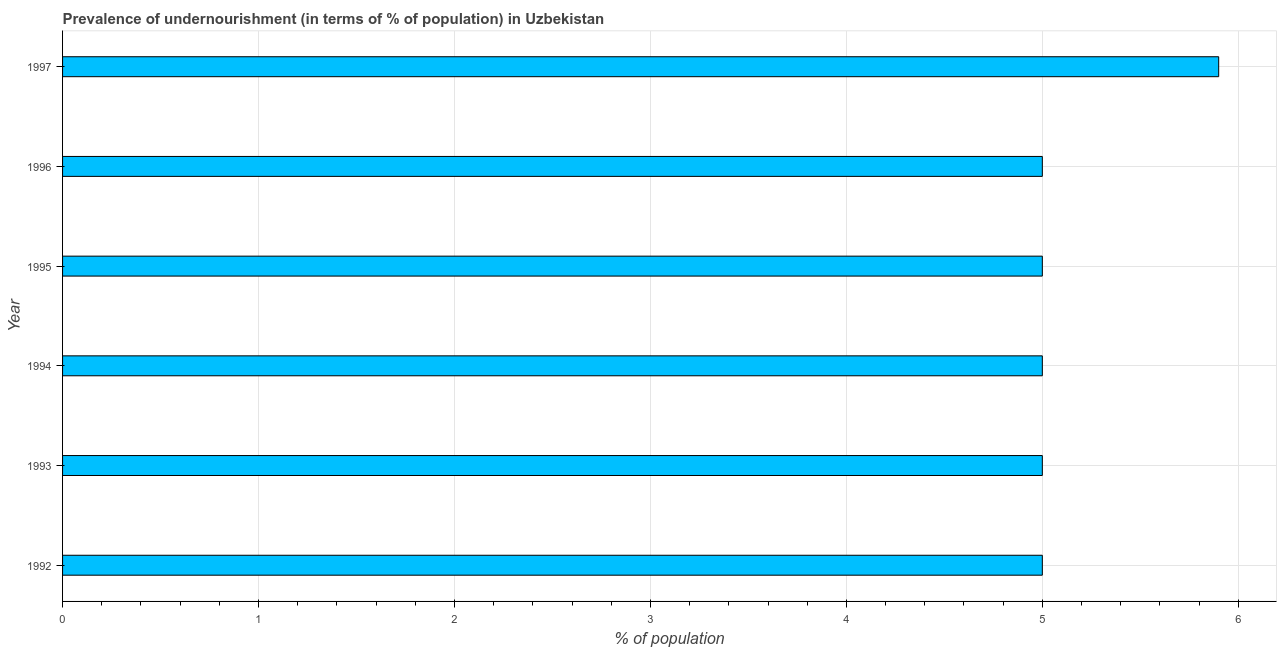Does the graph contain any zero values?
Your answer should be very brief. No. What is the title of the graph?
Ensure brevity in your answer.  Prevalence of undernourishment (in terms of % of population) in Uzbekistan. What is the label or title of the X-axis?
Provide a succinct answer. % of population. What is the sum of the percentage of undernourished population?
Your answer should be very brief. 30.9. What is the difference between the percentage of undernourished population in 1993 and 1997?
Make the answer very short. -0.9. What is the average percentage of undernourished population per year?
Your answer should be very brief. 5.15. What is the ratio of the percentage of undernourished population in 1992 to that in 1996?
Provide a succinct answer. 1. What is the difference between the highest and the lowest percentage of undernourished population?
Offer a very short reply. 0.9. Are all the bars in the graph horizontal?
Make the answer very short. Yes. How many years are there in the graph?
Provide a short and direct response. 6. What is the difference between two consecutive major ticks on the X-axis?
Your answer should be very brief. 1. What is the % of population of 1993?
Offer a terse response. 5. What is the % of population of 1994?
Ensure brevity in your answer.  5. What is the % of population in 1995?
Your answer should be very brief. 5. What is the % of population of 1997?
Make the answer very short. 5.9. What is the difference between the % of population in 1992 and 1995?
Offer a terse response. 0. What is the difference between the % of population in 1992 and 1996?
Offer a very short reply. 0. What is the difference between the % of population in 1992 and 1997?
Your answer should be very brief. -0.9. What is the difference between the % of population in 1993 and 1994?
Give a very brief answer. 0. What is the difference between the % of population in 1993 and 1997?
Your answer should be compact. -0.9. What is the difference between the % of population in 1994 and 1996?
Offer a very short reply. 0. What is the difference between the % of population in 1994 and 1997?
Keep it short and to the point. -0.9. What is the ratio of the % of population in 1992 to that in 1993?
Provide a succinct answer. 1. What is the ratio of the % of population in 1992 to that in 1997?
Your response must be concise. 0.85. What is the ratio of the % of population in 1993 to that in 1994?
Provide a short and direct response. 1. What is the ratio of the % of population in 1993 to that in 1997?
Offer a very short reply. 0.85. What is the ratio of the % of population in 1994 to that in 1997?
Your answer should be very brief. 0.85. What is the ratio of the % of population in 1995 to that in 1997?
Make the answer very short. 0.85. What is the ratio of the % of population in 1996 to that in 1997?
Your answer should be very brief. 0.85. 